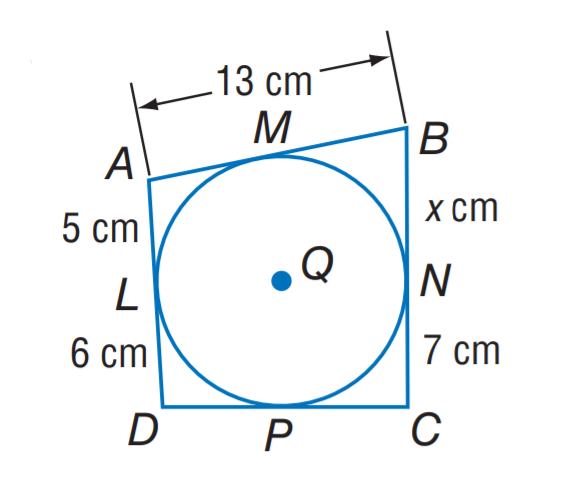Answer the mathemtical geometry problem and directly provide the correct option letter.
Question: Find x.
Choices: A: 7 B: 8 C: 11 D: 13 B 